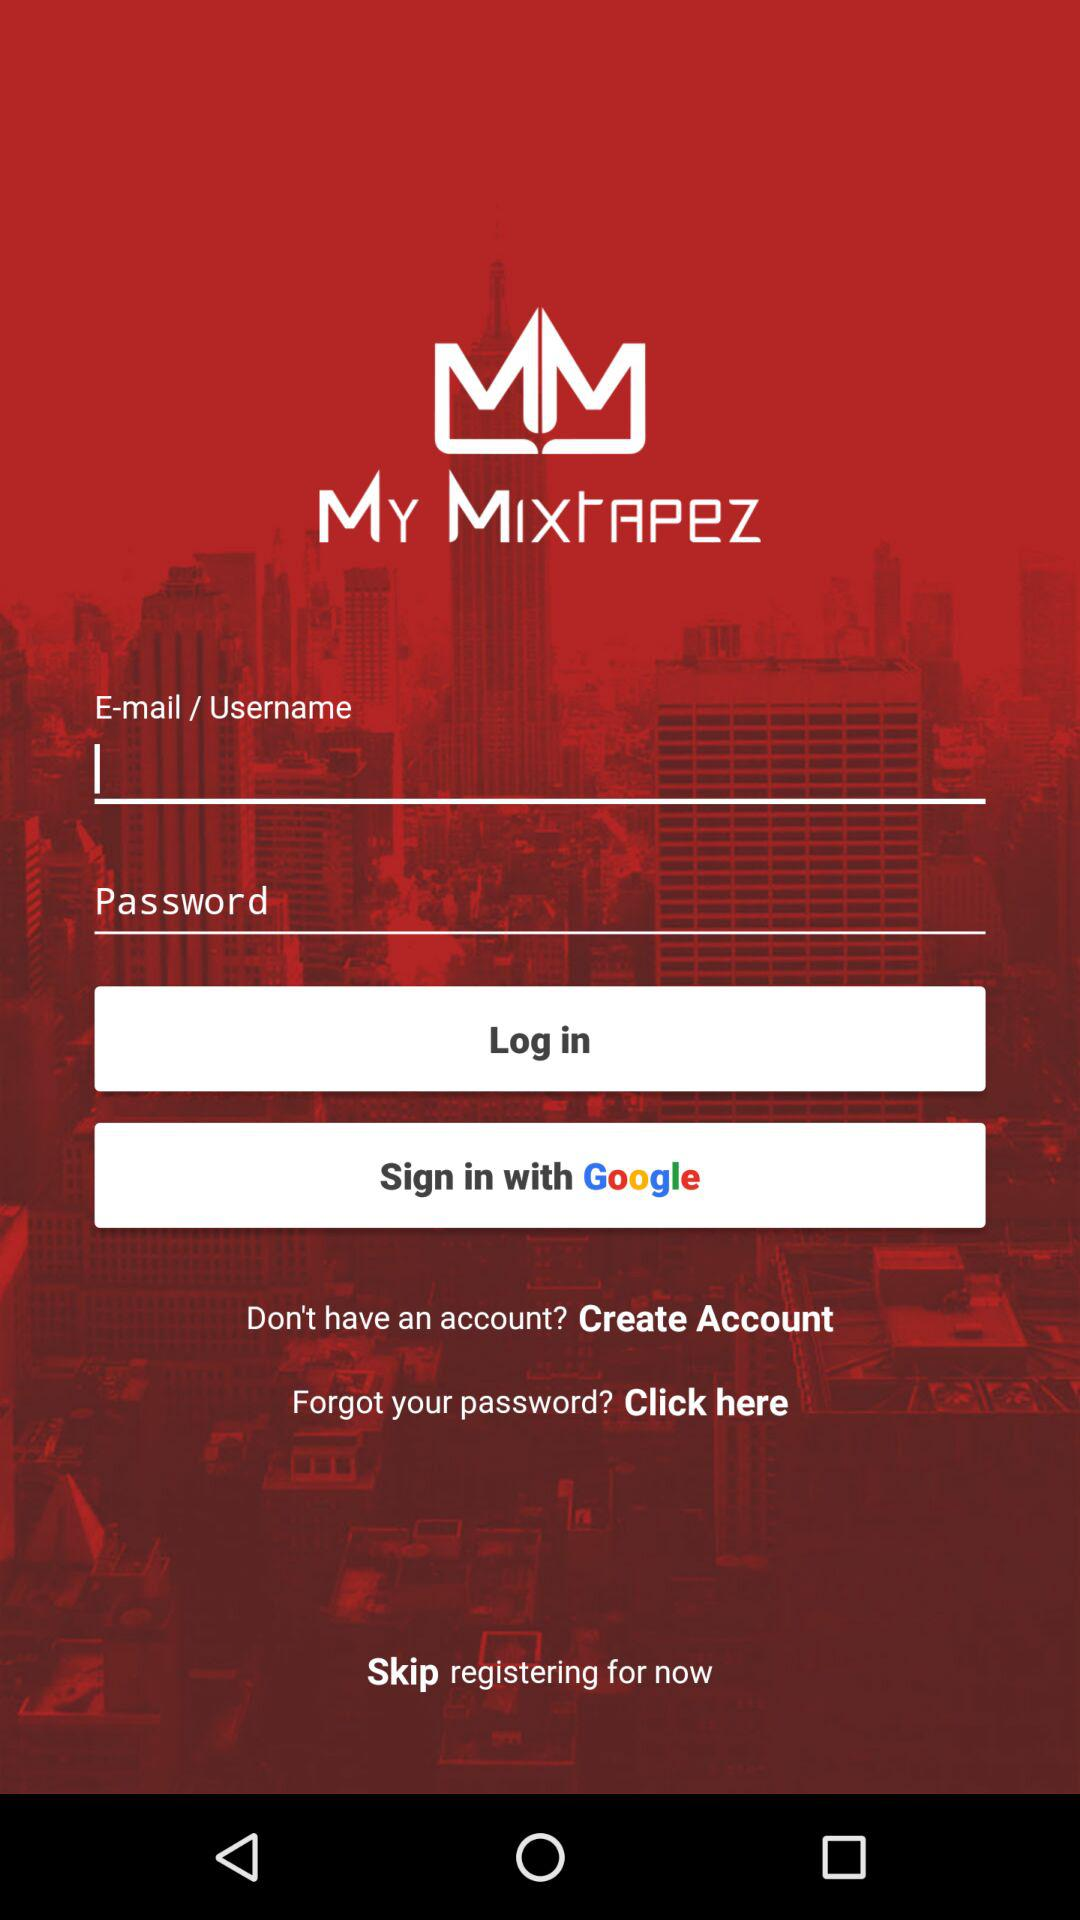What is the name of the application? The name of the application is "My Mixtapez". 